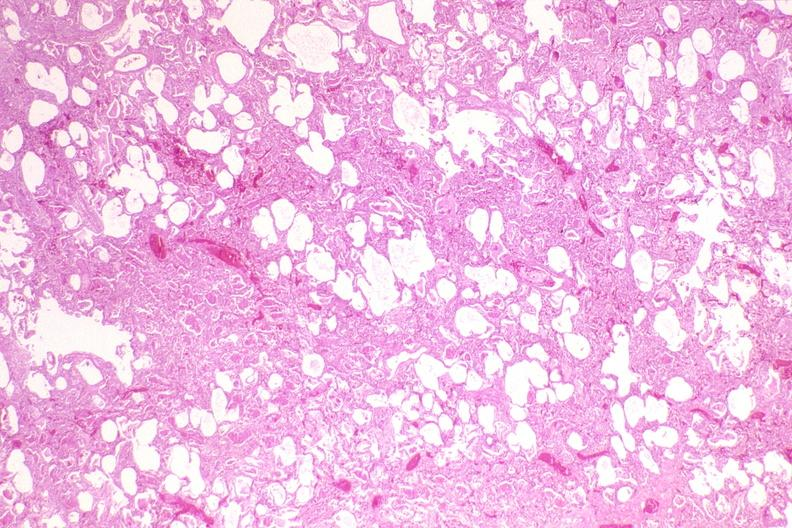does meningitis acute show lung, pneumocystis pneumonia?
Answer the question using a single word or phrase. No 